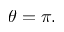Convert formula to latex. <formula><loc_0><loc_0><loc_500><loc_500>\theta = \pi .</formula> 